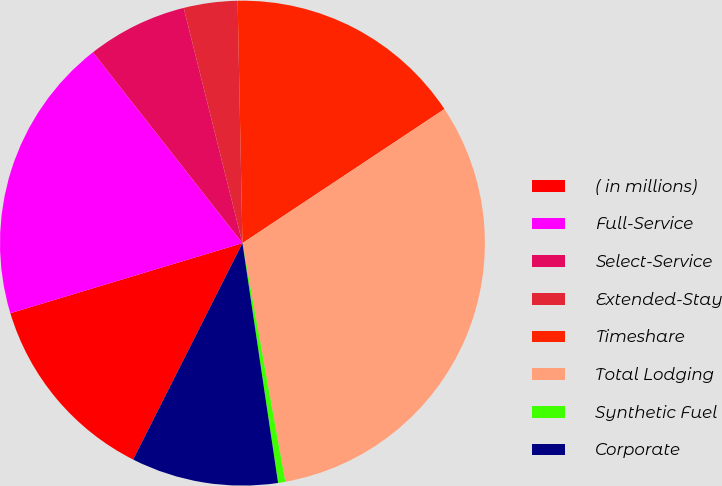<chart> <loc_0><loc_0><loc_500><loc_500><pie_chart><fcel>( in millions)<fcel>Full-Service<fcel>Select-Service<fcel>Extended-Stay<fcel>Timeshare<fcel>Total Lodging<fcel>Synthetic Fuel<fcel>Corporate<nl><fcel>12.89%<fcel>19.09%<fcel>6.68%<fcel>3.58%<fcel>15.99%<fcel>31.5%<fcel>0.48%<fcel>9.79%<nl></chart> 